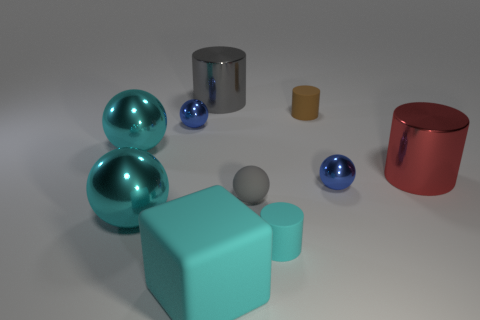What is the size of the gray metallic thing that is the same shape as the big red object?
Give a very brief answer. Large. Is there a gray rubber ball that is behind the gray object to the right of the large rubber object?
Your answer should be compact. No. What number of other objects are the same shape as the gray rubber thing?
Make the answer very short. 4. Are there more big cyan things to the left of the small cyan rubber object than tiny balls behind the large gray cylinder?
Keep it short and to the point. Yes. There is a gray matte thing that is behind the large rubber block; does it have the same size as the blue thing to the right of the big block?
Ensure brevity in your answer.  Yes. What is the shape of the large red thing?
Provide a short and direct response. Cylinder. There is a cylinder that is the same color as the matte sphere; what is its size?
Ensure brevity in your answer.  Large. The large cylinder that is the same material as the big red thing is what color?
Your response must be concise. Gray. Do the cyan block and the gray ball that is on the left side of the tiny brown matte cylinder have the same material?
Provide a short and direct response. Yes. The small matte sphere is what color?
Offer a very short reply. Gray. 